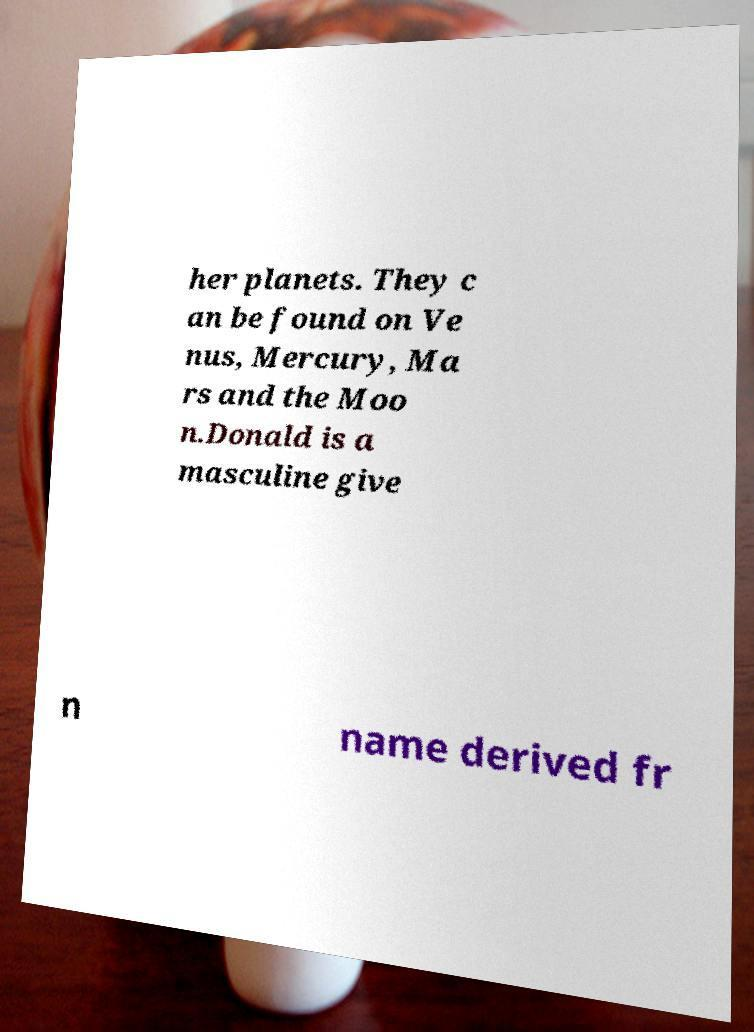Can you accurately transcribe the text from the provided image for me? her planets. They c an be found on Ve nus, Mercury, Ma rs and the Moo n.Donald is a masculine give n name derived fr 